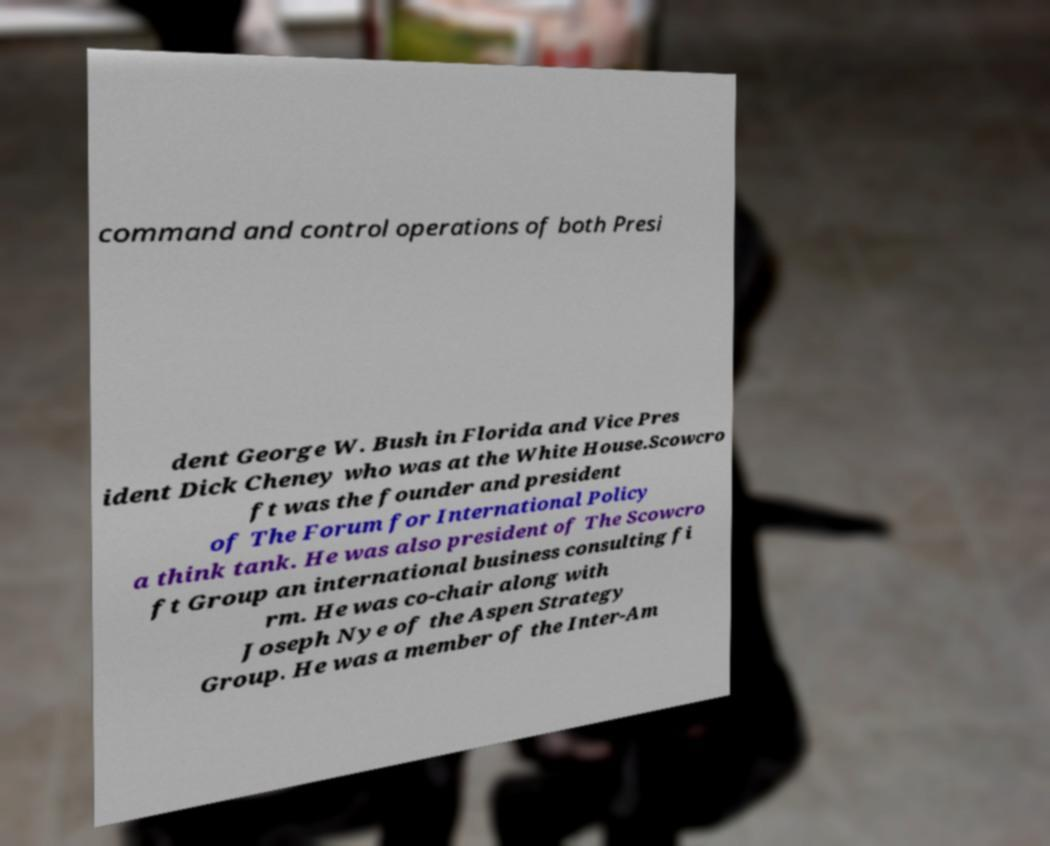Can you read and provide the text displayed in the image?This photo seems to have some interesting text. Can you extract and type it out for me? command and control operations of both Presi dent George W. Bush in Florida and Vice Pres ident Dick Cheney who was at the White House.Scowcro ft was the founder and president of The Forum for International Policy a think tank. He was also president of The Scowcro ft Group an international business consulting fi rm. He was co-chair along with Joseph Nye of the Aspen Strategy Group. He was a member of the Inter-Am 